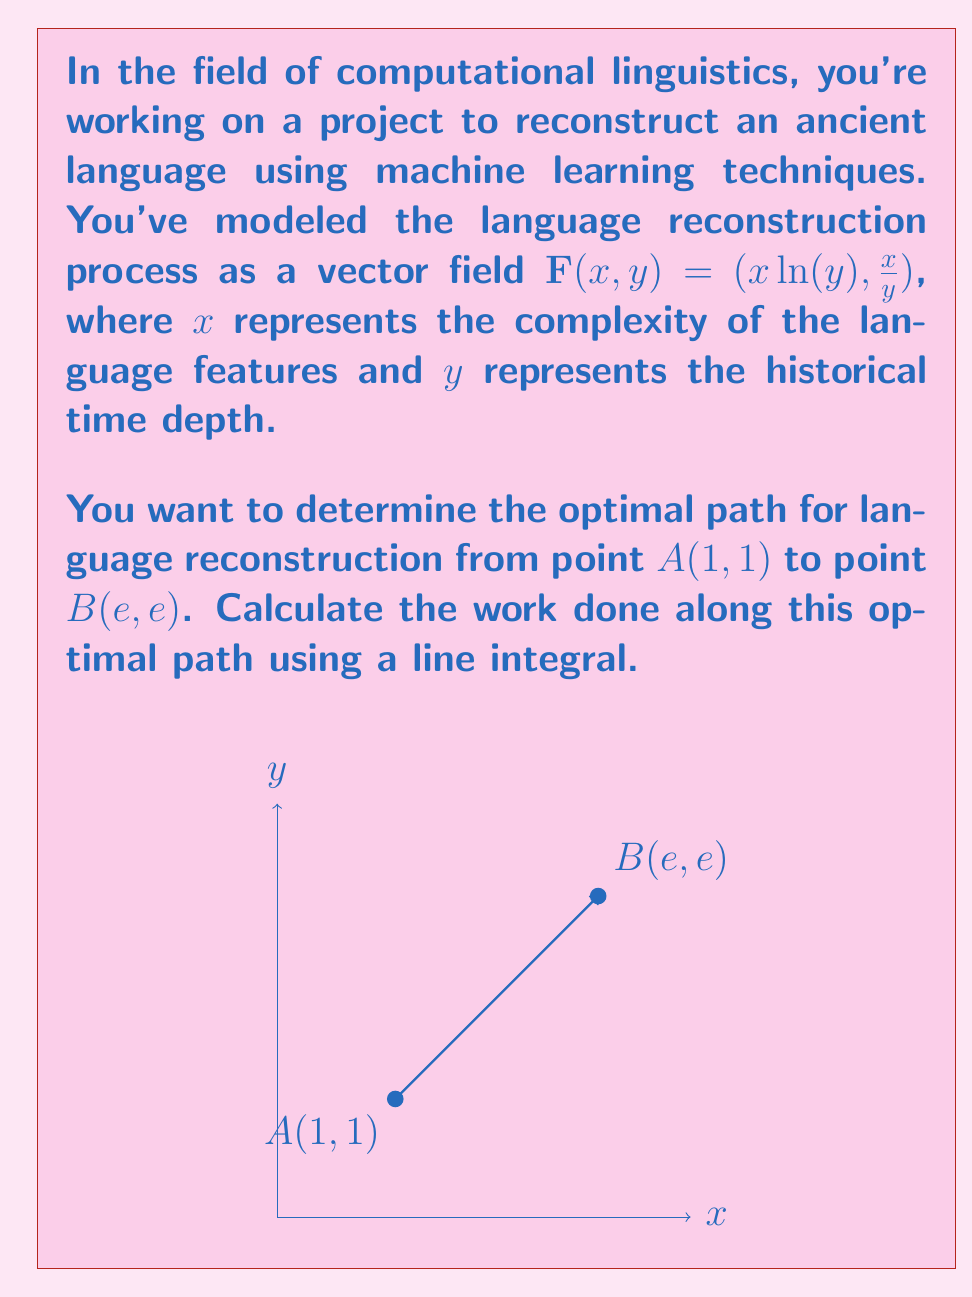Give your solution to this math problem. To solve this problem, we'll follow these steps:

1) The optimal path between two points in a conservative vector field is always a straight line. We can parameterize this line as:

   $x(t) = 1 + (e-1)t$
   $y(t) = 1 + (e-1)t$
   where $0 \leq t \leq 1$

2) The line integral along this path is given by:

   $$\int_C \mathbf{F} \cdot d\mathbf{r} = \int_0^1 \mathbf{F}(x(t),y(t)) \cdot \mathbf{r}'(t) dt$$

3) We need to calculate $\mathbf{r}'(t)$:
   
   $\mathbf{r}'(t) = (x'(t), y'(t)) = (e-1, e-1)$

4) Now, let's substitute everything into the integral:

   $$\int_0^1 [(1+(e-1)t)\ln(1+(e-1)t), \frac{1+(e-1)t}{1+(e-1)t}] \cdot (e-1, e-1) dt$$

5) Simplify:

   $$\int_0^1 [(1+(e-1)t)\ln(1+(e-1)t)(e-1) + (e-1)] dt$$

6) This can be further simplified to:

   $$(e-1)\int_0^1 [(1+(e-1)t)\ln(1+(e-1)t) + 1] dt$$

7) This integral can be solved using integration by parts. Let $u = \ln(1+(e-1)t)$ and $dv = (1+(e-1)t)dt$. After applying integration by parts and evaluating from 0 to 1, we get:

   $$(e-1)[t(1+(e-1)t)\ln(1+(e-1)t) - t]_0^1$$

8) Evaluate at the limits:

   $$(e-1)[e\ln e - e + 1] = (e-1)[1] = e-1$$
Answer: $e-1$ 